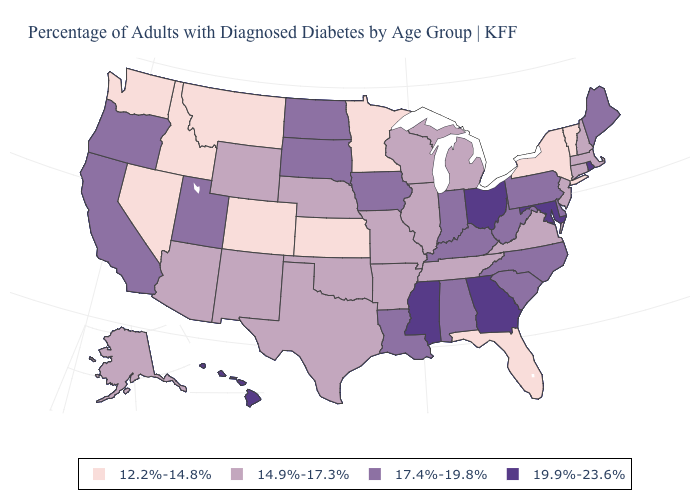Does Kansas have the lowest value in the USA?
Give a very brief answer. Yes. Among the states that border Oklahoma , does Arkansas have the highest value?
Write a very short answer. Yes. Which states have the lowest value in the Northeast?
Answer briefly. New York, Vermont. Does Ohio have the lowest value in the MidWest?
Give a very brief answer. No. Name the states that have a value in the range 12.2%-14.8%?
Keep it brief. Colorado, Florida, Idaho, Kansas, Minnesota, Montana, Nevada, New York, Vermont, Washington. Which states have the lowest value in the USA?
Quick response, please. Colorado, Florida, Idaho, Kansas, Minnesota, Montana, Nevada, New York, Vermont, Washington. How many symbols are there in the legend?
Answer briefly. 4. What is the value of New Mexico?
Answer briefly. 14.9%-17.3%. What is the value of Alaska?
Quick response, please. 14.9%-17.3%. What is the value of Nebraska?
Be succinct. 14.9%-17.3%. Does Tennessee have the lowest value in the USA?
Keep it brief. No. Name the states that have a value in the range 17.4%-19.8%?
Keep it brief. Alabama, California, Delaware, Indiana, Iowa, Kentucky, Louisiana, Maine, North Carolina, North Dakota, Oregon, Pennsylvania, South Carolina, South Dakota, Utah, West Virginia. Among the states that border Pennsylvania , does New Jersey have the highest value?
Keep it brief. No. What is the lowest value in the USA?
Short answer required. 12.2%-14.8%. Does Ohio have the highest value in the USA?
Write a very short answer. Yes. 